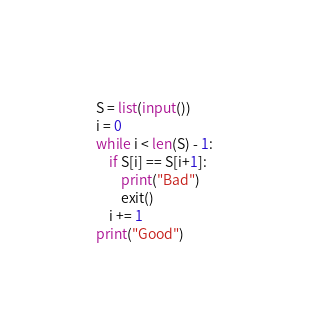Convert code to text. <code><loc_0><loc_0><loc_500><loc_500><_Python_>S = list(input())
i = 0
while i < len(S) - 1:
    if S[i] == S[i+1]:
        print("Bad")
        exit()
    i += 1
print("Good")
</code> 